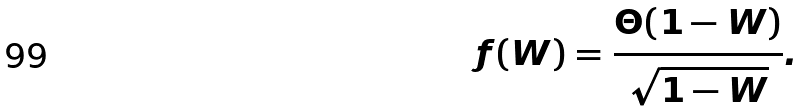<formula> <loc_0><loc_0><loc_500><loc_500>f ( W ) = \frac { \Theta ( 1 - W ) } { \sqrt { 1 - W } } .</formula> 